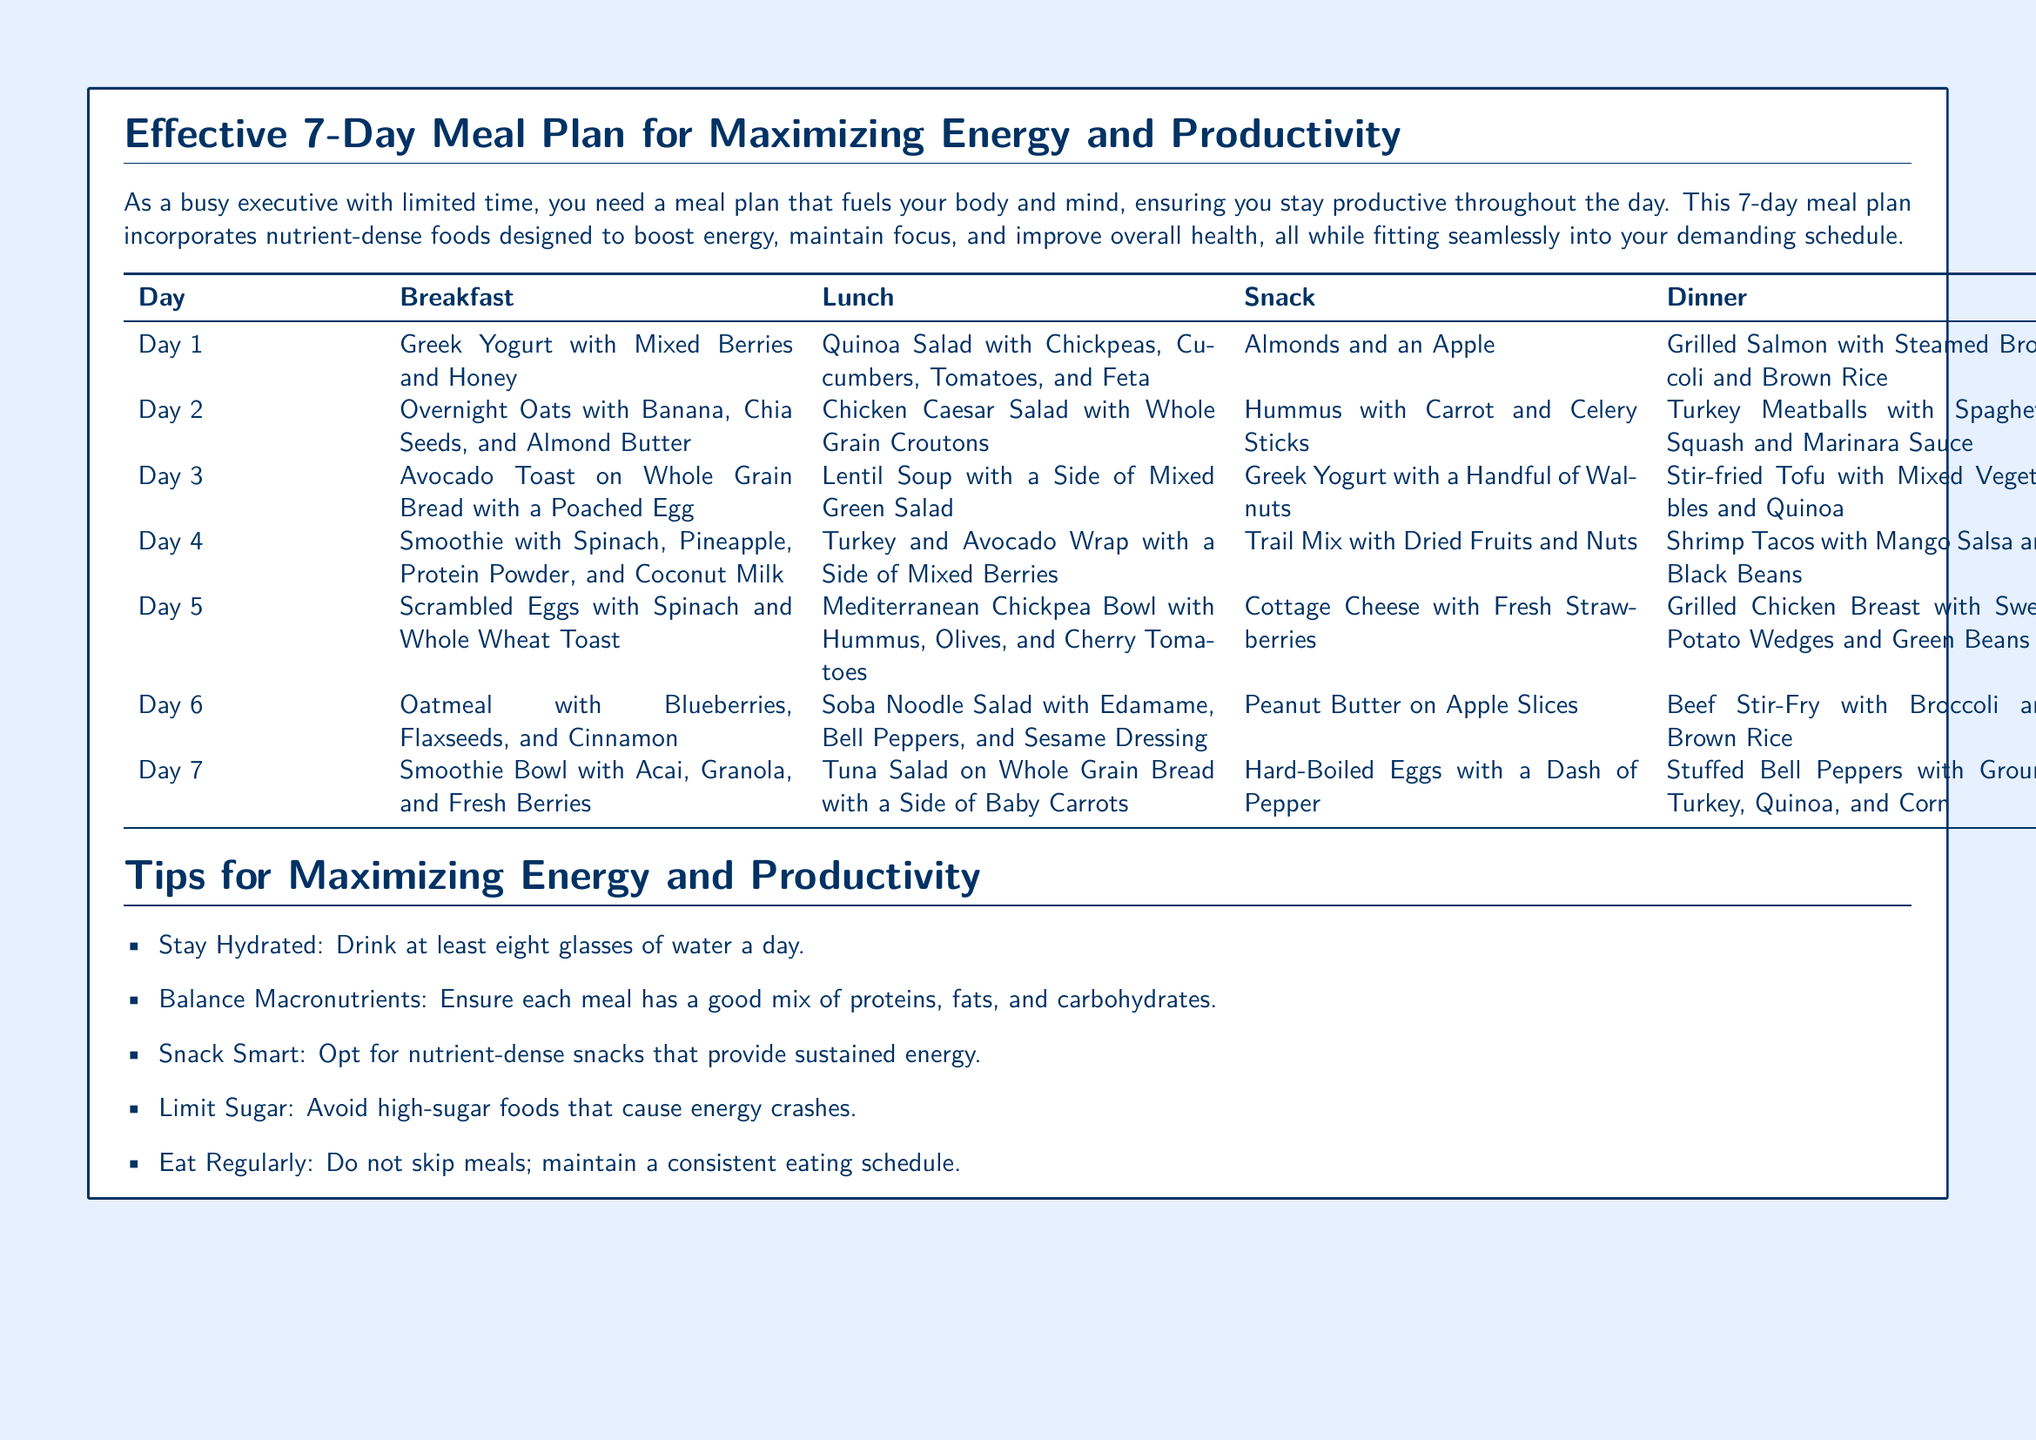What is the main focus of the meal plan? The document is centered around a meal plan designed to enhance energy and productivity for busy executives.
Answer: energy and productivity How many days does the meal plan cover? The meal plan details meals for each of the seven days, as indicated in the title.
Answer: 7 days What is included in the breakfast for Day 5? The breakfast for Day 5 consists of scrambled eggs with spinach and whole wheat toast.
Answer: Scrambled Eggs with Spinach and Whole Wheat Toast What type of salad is served for lunch on Day 2? The lunch on Day 2 is a Chicken Caesar Salad that includes whole grain croutons.
Answer: Chicken Caesar Salad with Whole Grain Croutons Which day features a smoothie as breakfast? A smoothie is included in the breakfast options for Day 4 and Day 7.
Answer: Day 4, Day 7 What are two tips given for maximizing energy? The document provides multiple tips, including staying hydrated and balancing macronutrients.
Answer: Stay Hydrated, Balance Macronutrients What is the dinner for Day 3? The dinner listed for Day 3 is stir-fried tofu with mixed vegetables and quinoa.
Answer: Stir-fried Tofu with Mixed Vegetables and Quinoa What snack is suggested for Day 6? The snack for Day 6 is peanut butter on apple slices.
Answer: Peanut Butter on Apple Slices What kind of nuts are suggested for a snack on Day 1? The snack for Day 1 includes almonds and an apple.
Answer: Almonds and an Apple 